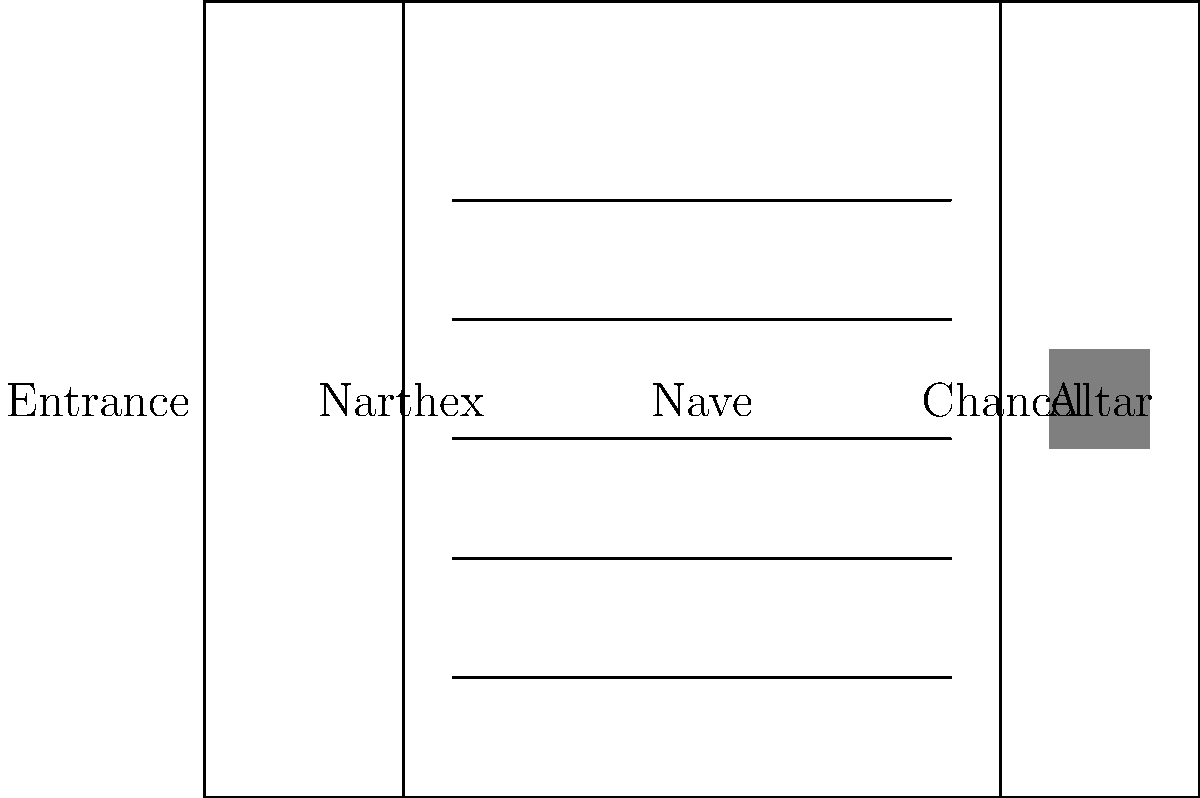In a typical Christian church floor plan, which area is located between the Narthex and the Chancel, and often contains seating for the congregation? To answer this question, let's break down the components of a typical Christian church floor plan:

1. Narthex: This is the entrance or lobby area of the church, usually located at the rear of the building. It serves as a transitional space between the outside world and the main worship area.

2. Nave: This is the central and main part of the church where the congregation sits during services. It typically extends from the entrance (or narthex) to the chancel.

3. Chancel: This is the area around the altar, often raised and separated from the nave by steps or a railing. It's where the clergy conduct the service and where the choir may be located.

4. Altar: This is the focal point of the church, usually located at the far end of the chancel.

In the floor plan provided, we can see these elements laid out in a typical arrangement:

- The Narthex is at the entrance (left side of the diagram).
- The Chancel, containing the Altar, is at the far end (right side of the diagram).
- Between these two areas, we see a large space with rows of seating (pews). This central area is the Nave.

Therefore, the area located between the Narthex and the Chancel, which contains seating for the congregation, is the Nave.
Answer: Nave 